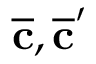Convert formula to latex. <formula><loc_0><loc_0><loc_500><loc_500>\overline { c } , \overline { c } ^ { \prime }</formula> 